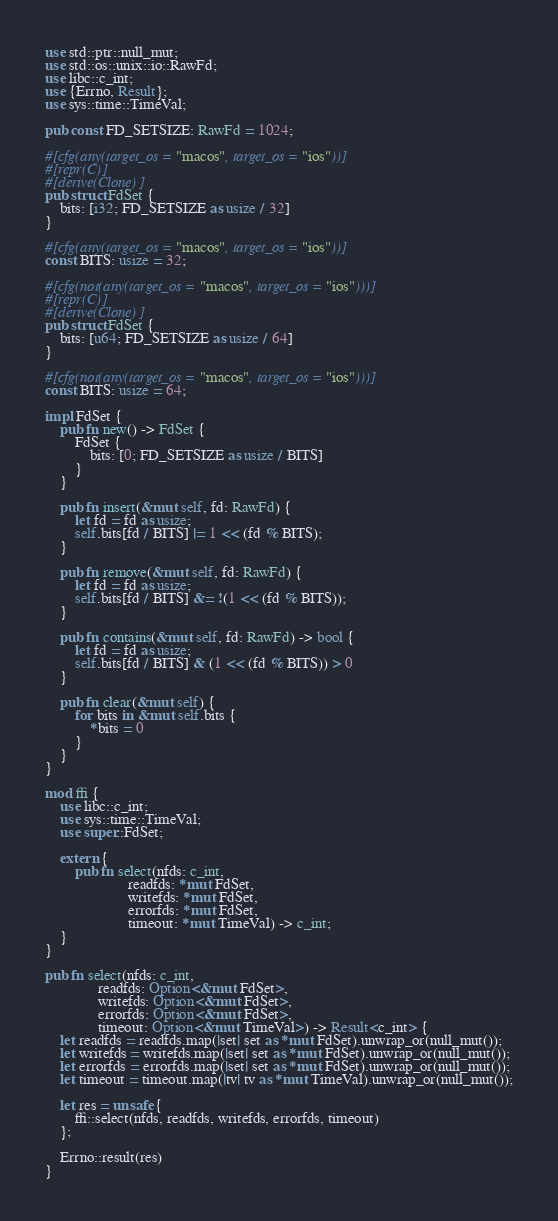Convert code to text. <code><loc_0><loc_0><loc_500><loc_500><_Rust_>use std::ptr::null_mut;
use std::os::unix::io::RawFd;
use libc::c_int;
use {Errno, Result};
use sys::time::TimeVal;

pub const FD_SETSIZE: RawFd = 1024;

#[cfg(any(target_os = "macos", target_os = "ios"))]
#[repr(C)]
#[derive(Clone)]
pub struct FdSet {
    bits: [i32; FD_SETSIZE as usize / 32]
}

#[cfg(any(target_os = "macos", target_os = "ios"))]
const BITS: usize = 32;

#[cfg(not(any(target_os = "macos", target_os = "ios")))]
#[repr(C)]
#[derive(Clone)]
pub struct FdSet {
    bits: [u64; FD_SETSIZE as usize / 64]
}

#[cfg(not(any(target_os = "macos", target_os = "ios")))]
const BITS: usize = 64;

impl FdSet {
    pub fn new() -> FdSet {
        FdSet {
            bits: [0; FD_SETSIZE as usize / BITS]
        }
    }

    pub fn insert(&mut self, fd: RawFd) {
        let fd = fd as usize;
        self.bits[fd / BITS] |= 1 << (fd % BITS);
    }

    pub fn remove(&mut self, fd: RawFd) {
        let fd = fd as usize;
        self.bits[fd / BITS] &= !(1 << (fd % BITS));
    }

    pub fn contains(&mut self, fd: RawFd) -> bool {
        let fd = fd as usize;
        self.bits[fd / BITS] & (1 << (fd % BITS)) > 0
    }

    pub fn clear(&mut self) {
        for bits in &mut self.bits {
            *bits = 0
        }
    }
}

mod ffi {
    use libc::c_int;
    use sys::time::TimeVal;
    use super::FdSet;

    extern {
        pub fn select(nfds: c_int,
                      readfds: *mut FdSet,
                      writefds: *mut FdSet,
                      errorfds: *mut FdSet,
                      timeout: *mut TimeVal) -> c_int;
    }
}

pub fn select(nfds: c_int,
              readfds: Option<&mut FdSet>,
              writefds: Option<&mut FdSet>,
              errorfds: Option<&mut FdSet>,
              timeout: Option<&mut TimeVal>) -> Result<c_int> {
    let readfds = readfds.map(|set| set as *mut FdSet).unwrap_or(null_mut());
    let writefds = writefds.map(|set| set as *mut FdSet).unwrap_or(null_mut());
    let errorfds = errorfds.map(|set| set as *mut FdSet).unwrap_or(null_mut());
    let timeout = timeout.map(|tv| tv as *mut TimeVal).unwrap_or(null_mut());

    let res = unsafe {
        ffi::select(nfds, readfds, writefds, errorfds, timeout)
    };

    Errno::result(res)
}
</code> 